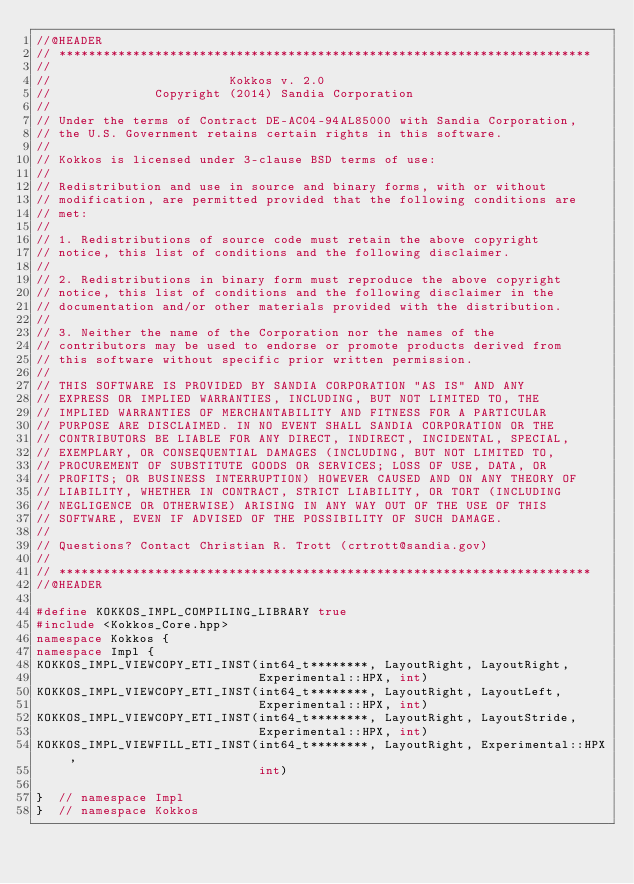<code> <loc_0><loc_0><loc_500><loc_500><_C++_>//@HEADER
// ************************************************************************
//
//                        Kokkos v. 2.0
//              Copyright (2014) Sandia Corporation
//
// Under the terms of Contract DE-AC04-94AL85000 with Sandia Corporation,
// the U.S. Government retains certain rights in this software.
//
// Kokkos is licensed under 3-clause BSD terms of use:
//
// Redistribution and use in source and binary forms, with or without
// modification, are permitted provided that the following conditions are
// met:
//
// 1. Redistributions of source code must retain the above copyright
// notice, this list of conditions and the following disclaimer.
//
// 2. Redistributions in binary form must reproduce the above copyright
// notice, this list of conditions and the following disclaimer in the
// documentation and/or other materials provided with the distribution.
//
// 3. Neither the name of the Corporation nor the names of the
// contributors may be used to endorse or promote products derived from
// this software without specific prior written permission.
//
// THIS SOFTWARE IS PROVIDED BY SANDIA CORPORATION "AS IS" AND ANY
// EXPRESS OR IMPLIED WARRANTIES, INCLUDING, BUT NOT LIMITED TO, THE
// IMPLIED WARRANTIES OF MERCHANTABILITY AND FITNESS FOR A PARTICULAR
// PURPOSE ARE DISCLAIMED. IN NO EVENT SHALL SANDIA CORPORATION OR THE
// CONTRIBUTORS BE LIABLE FOR ANY DIRECT, INDIRECT, INCIDENTAL, SPECIAL,
// EXEMPLARY, OR CONSEQUENTIAL DAMAGES (INCLUDING, BUT NOT LIMITED TO,
// PROCUREMENT OF SUBSTITUTE GOODS OR SERVICES; LOSS OF USE, DATA, OR
// PROFITS; OR BUSINESS INTERRUPTION) HOWEVER CAUSED AND ON ANY THEORY OF
// LIABILITY, WHETHER IN CONTRACT, STRICT LIABILITY, OR TORT (INCLUDING
// NEGLIGENCE OR OTHERWISE) ARISING IN ANY WAY OUT OF THE USE OF THIS
// SOFTWARE, EVEN IF ADVISED OF THE POSSIBILITY OF SUCH DAMAGE.
//
// Questions? Contact Christian R. Trott (crtrott@sandia.gov)
//
// ************************************************************************
//@HEADER

#define KOKKOS_IMPL_COMPILING_LIBRARY true
#include <Kokkos_Core.hpp>
namespace Kokkos {
namespace Impl {
KOKKOS_IMPL_VIEWCOPY_ETI_INST(int64_t********, LayoutRight, LayoutRight,
                              Experimental::HPX, int)
KOKKOS_IMPL_VIEWCOPY_ETI_INST(int64_t********, LayoutRight, LayoutLeft,
                              Experimental::HPX, int)
KOKKOS_IMPL_VIEWCOPY_ETI_INST(int64_t********, LayoutRight, LayoutStride,
                              Experimental::HPX, int)
KOKKOS_IMPL_VIEWFILL_ETI_INST(int64_t********, LayoutRight, Experimental::HPX,
                              int)

}  // namespace Impl
}  // namespace Kokkos
</code> 